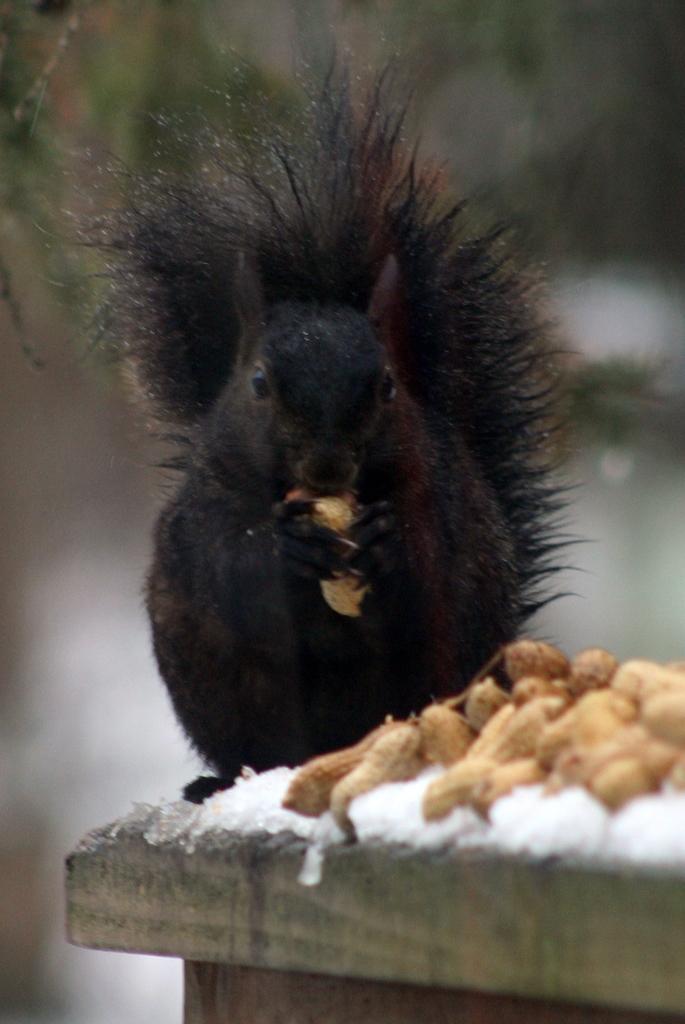How would you summarize this image in a sentence or two? In the picture I can see black color squirrel standing on the wooden surface. Here we can see peanuts, ice and the background of the image is blurred. 